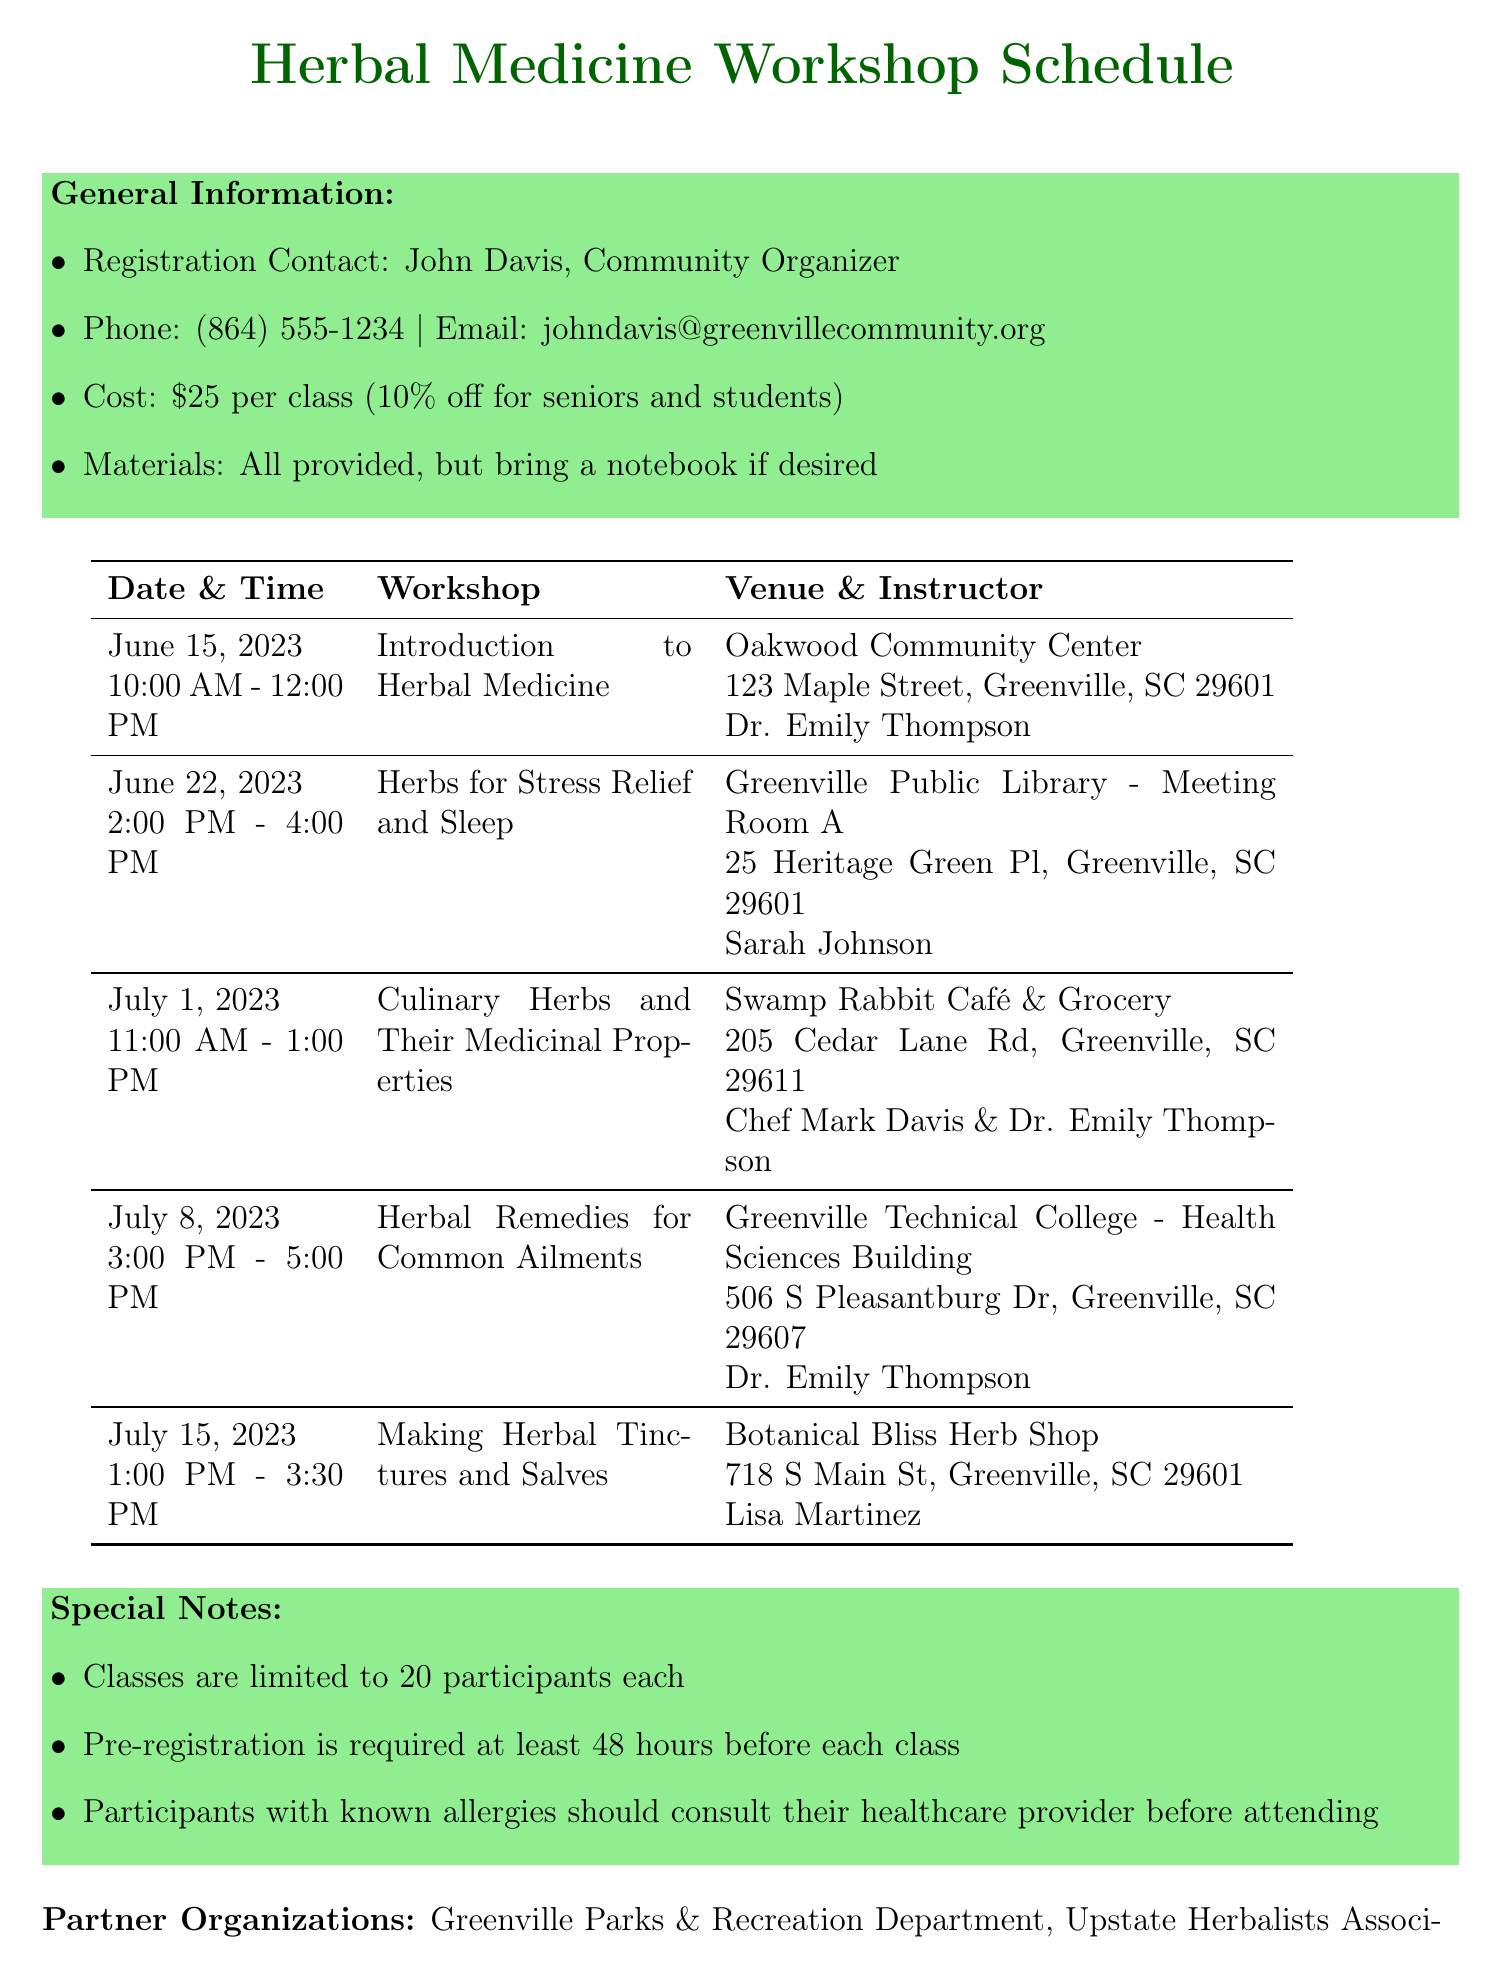What is the title of the first workshop? The first workshop's title is "Introduction to Herbal Medicine," which can be found in the schedule.
Answer: Introduction to Herbal Medicine Who is the instructor for the workshop on July 1, 2023? The instructor for the Culinary Herbs workshop on July 1, 2023, is listed as Chef Mark Davis & Dr. Emily Thompson.
Answer: Chef Mark Davis & Dr. Emily Thompson What is the cost of attending one class? The document states that the cost per class is $25.
Answer: $25 How long is the workshop on July 15, 2023? The duration of the workshop on July 15, 2023, is provided in the schedule as 2.5 hours (from 1:00 PM to 3:30 PM).
Answer: 2.5 hours What is the maximum number of participants allowed in each class? The document specifies that classes are limited to 20 participants each, indicating the participant limit.
Answer: 20 participants Which community organization is hosting the workshops? The document identifies John Davis as the Community Organizer, providing the name of the key person involved.
Answer: John Davis Which venue hosts the workshop titled "Herbal Remedies for Common Ailments"? The venue for this workshop is the Greenville Technical College - Health Sciences Building, as indicated in the schedule.
Answer: Greenville Technical College - Health Sciences Building Are materials provided for the classes? Yes, the document mentions that all materials are provided for the classes.
Answer: Yes What discount is available for seniors and students? The schedule states a 10% discount for seniors and students, highlighting the offered discount.
Answer: 10% discount 